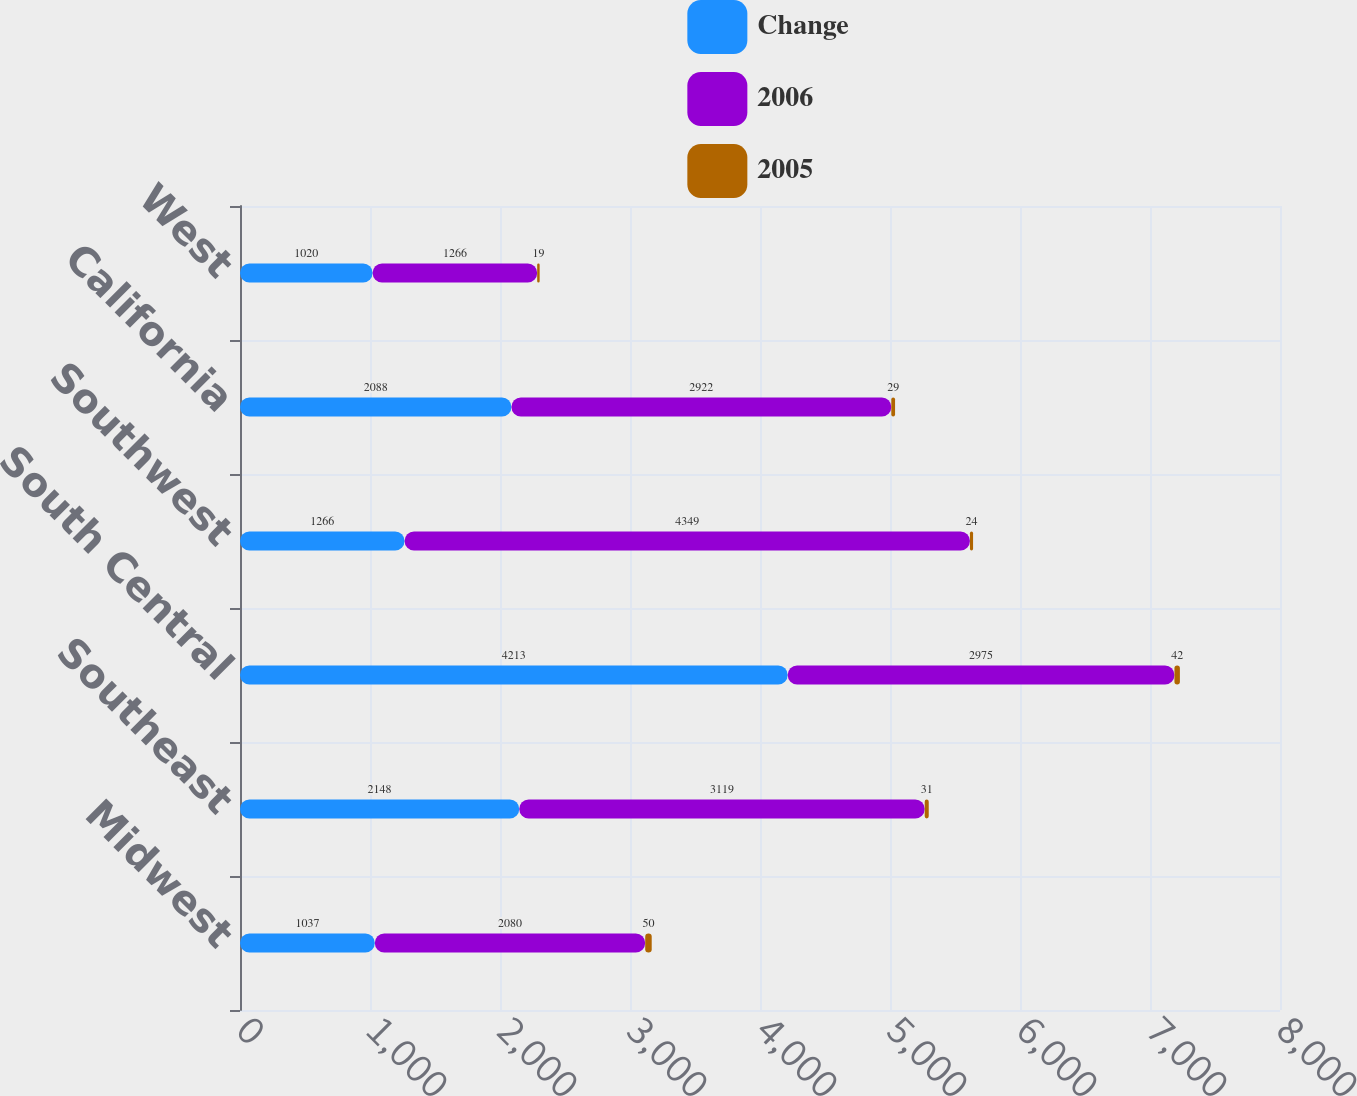<chart> <loc_0><loc_0><loc_500><loc_500><stacked_bar_chart><ecel><fcel>Midwest<fcel>Southeast<fcel>South Central<fcel>Southwest<fcel>California<fcel>West<nl><fcel>Change<fcel>1037<fcel>2148<fcel>4213<fcel>1266<fcel>2088<fcel>1020<nl><fcel>2006<fcel>2080<fcel>3119<fcel>2975<fcel>4349<fcel>2922<fcel>1266<nl><fcel>2005<fcel>50<fcel>31<fcel>42<fcel>24<fcel>29<fcel>19<nl></chart> 